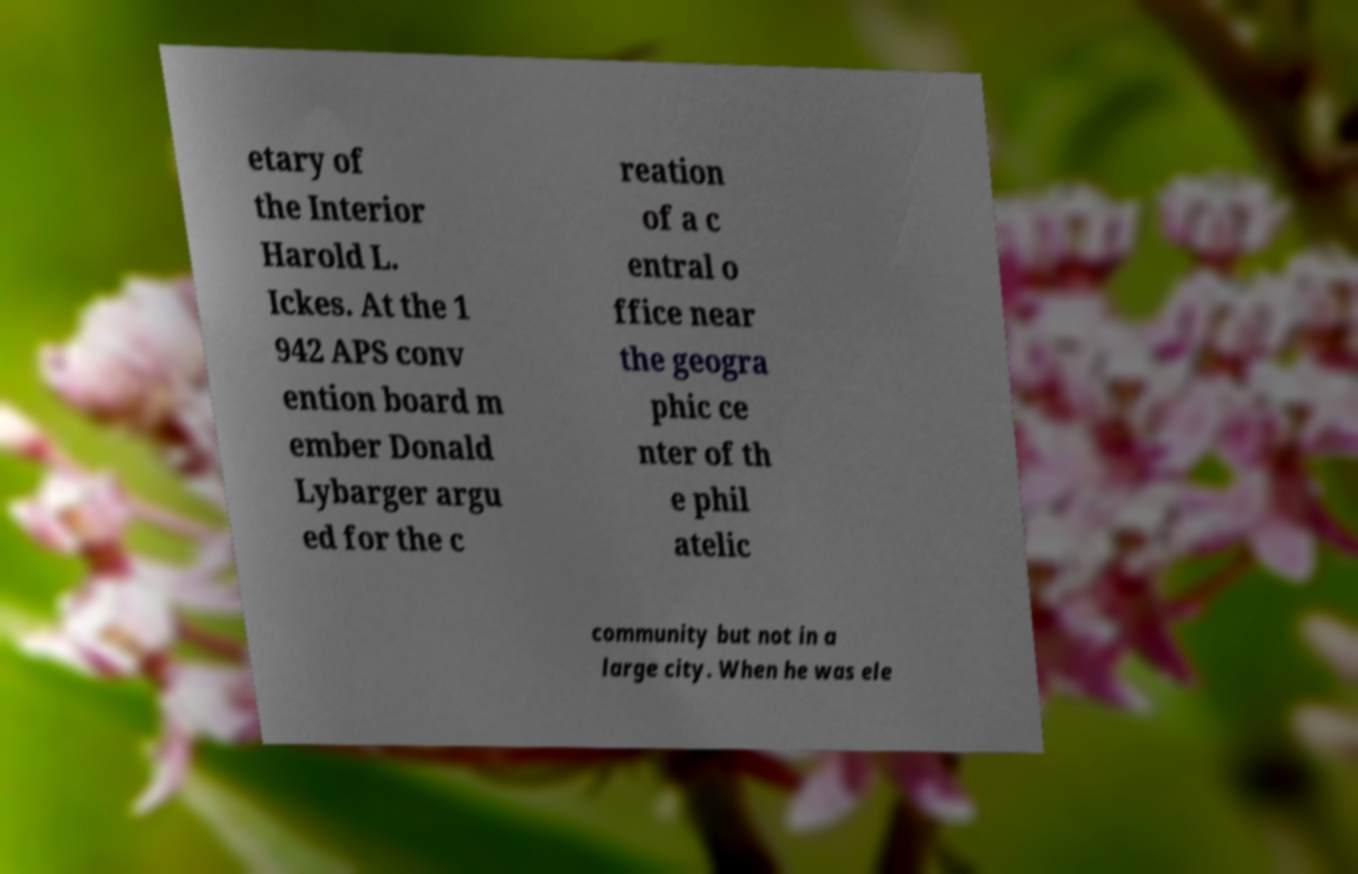I need the written content from this picture converted into text. Can you do that? etary of the Interior Harold L. Ickes. At the 1 942 APS conv ention board m ember Donald Lybarger argu ed for the c reation of a c entral o ffice near the geogra phic ce nter of th e phil atelic community but not in a large city. When he was ele 